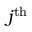<formula> <loc_0><loc_0><loc_500><loc_500>j ^ { t h }</formula> 